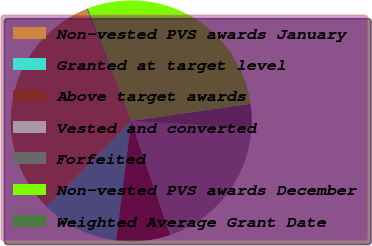Convert chart to OTSL. <chart><loc_0><loc_0><loc_500><loc_500><pie_chart><fcel>Non-vested PVS awards January<fcel>Granted at target level<fcel>Above target awards<fcel>Vested and converted<fcel>Forfeited<fcel>Non-vested PVS awards December<fcel>Weighted Average Grant Date<nl><fcel>31.57%<fcel>10.35%<fcel>7.27%<fcel>18.81%<fcel>3.21%<fcel>28.58%<fcel>0.22%<nl></chart> 